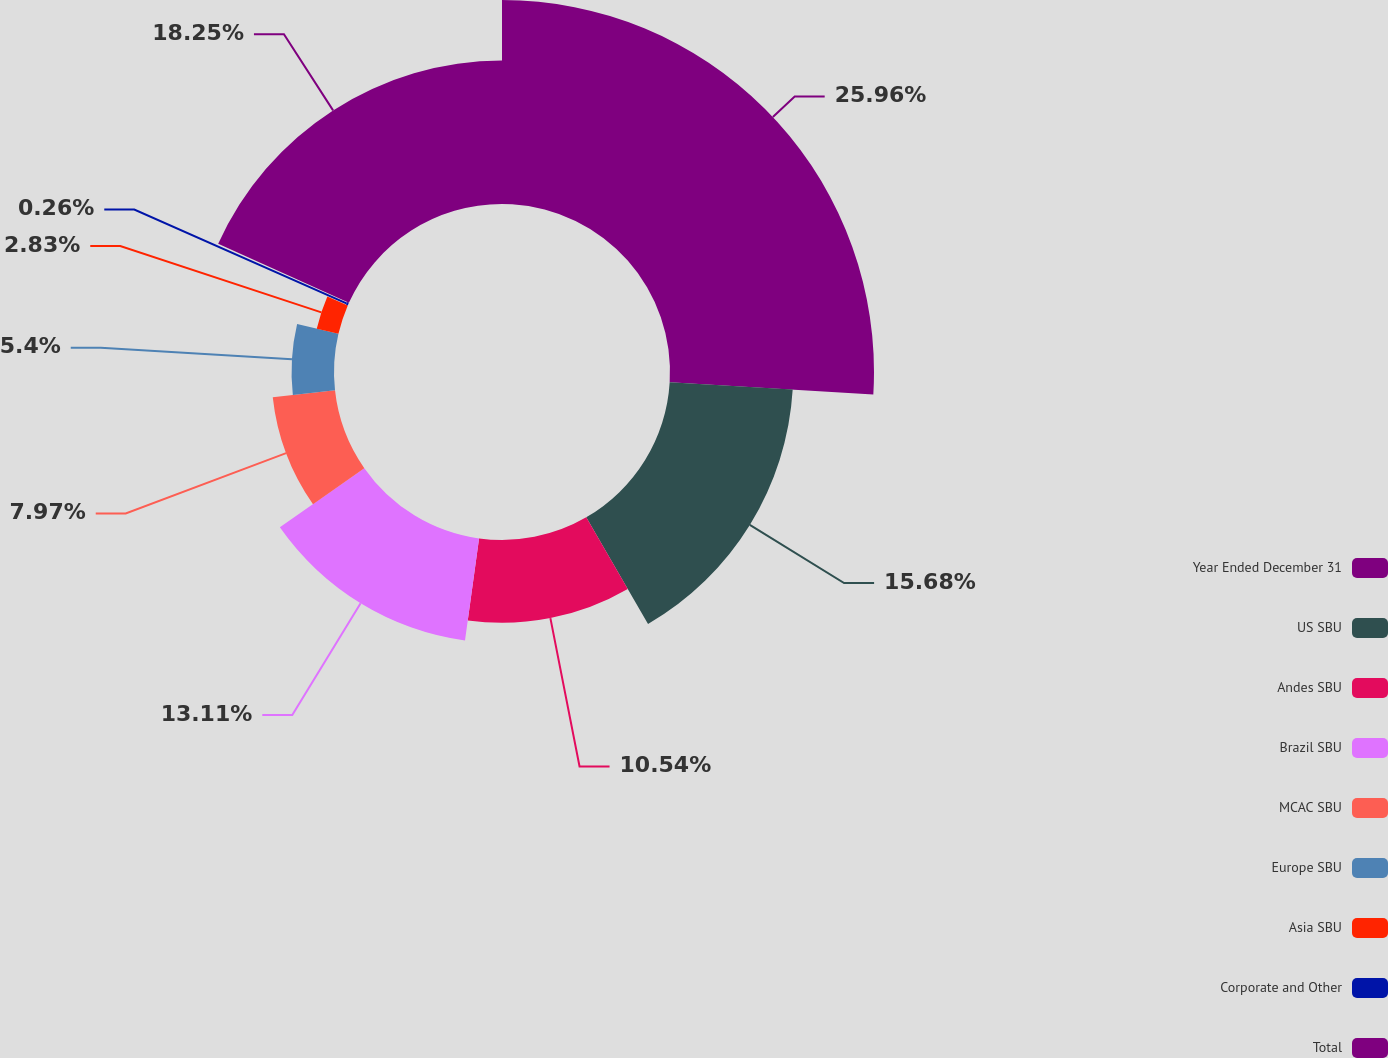Convert chart. <chart><loc_0><loc_0><loc_500><loc_500><pie_chart><fcel>Year Ended December 31<fcel>US SBU<fcel>Andes SBU<fcel>Brazil SBU<fcel>MCAC SBU<fcel>Europe SBU<fcel>Asia SBU<fcel>Corporate and Other<fcel>Total<nl><fcel>25.96%<fcel>15.68%<fcel>10.54%<fcel>13.11%<fcel>7.97%<fcel>5.4%<fcel>2.83%<fcel>0.26%<fcel>18.25%<nl></chart> 